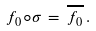<formula> <loc_0><loc_0><loc_500><loc_500>f _ { 0 } \circ \sigma \, = \, \overline { f _ { 0 } } \, .</formula> 